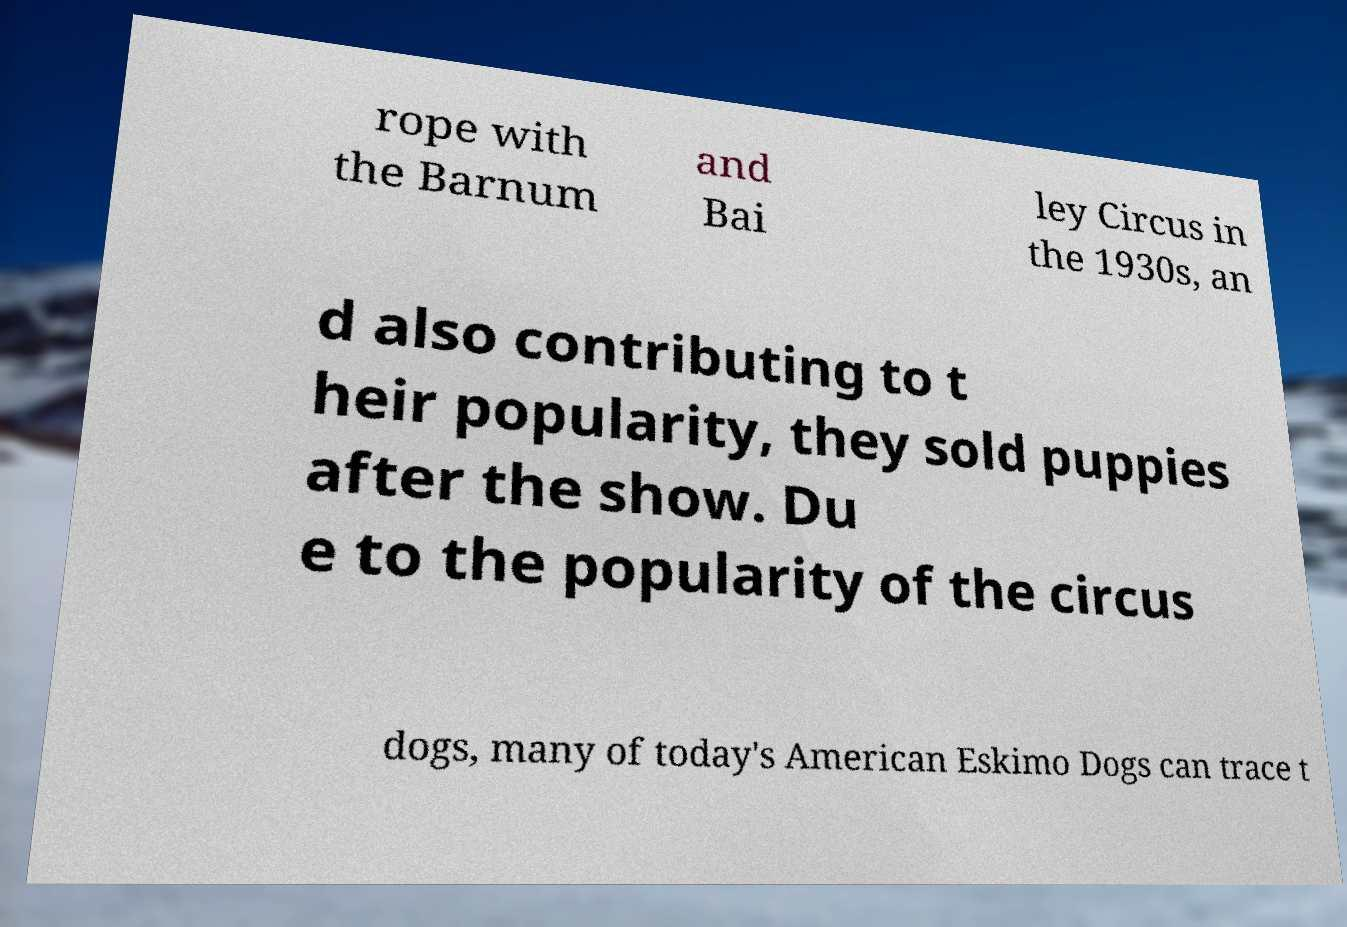Please identify and transcribe the text found in this image. rope with the Barnum and Bai ley Circus in the 1930s, an d also contributing to t heir popularity, they sold puppies after the show. Du e to the popularity of the circus dogs, many of today's American Eskimo Dogs can trace t 